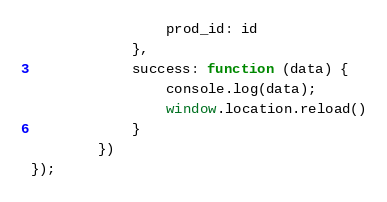Convert code to text. <code><loc_0><loc_0><loc_500><loc_500><_JavaScript_>                prod_id: id
            },
            success: function (data) {
                console.log(data);
                window.location.reload()
            }
        })
});


</code> 